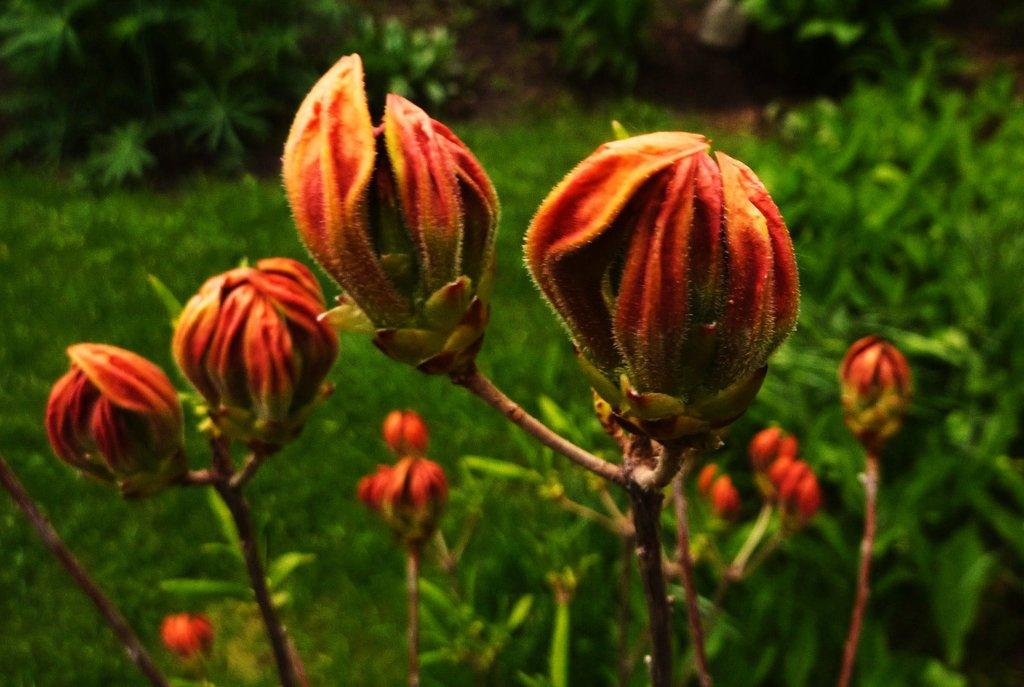What type of plants can be seen in the image? There are plants with flowers in the image. Where are the plants located on the right side of the image? The plants are on the grassland on the right side of the image. Can you describe the plants visible at the top of the image? There are plants visible at the top of the image. What type of honey is being produced by the plants in the image? There is no indication in the image that the plants are producing honey, so it cannot be determined from the picture. 